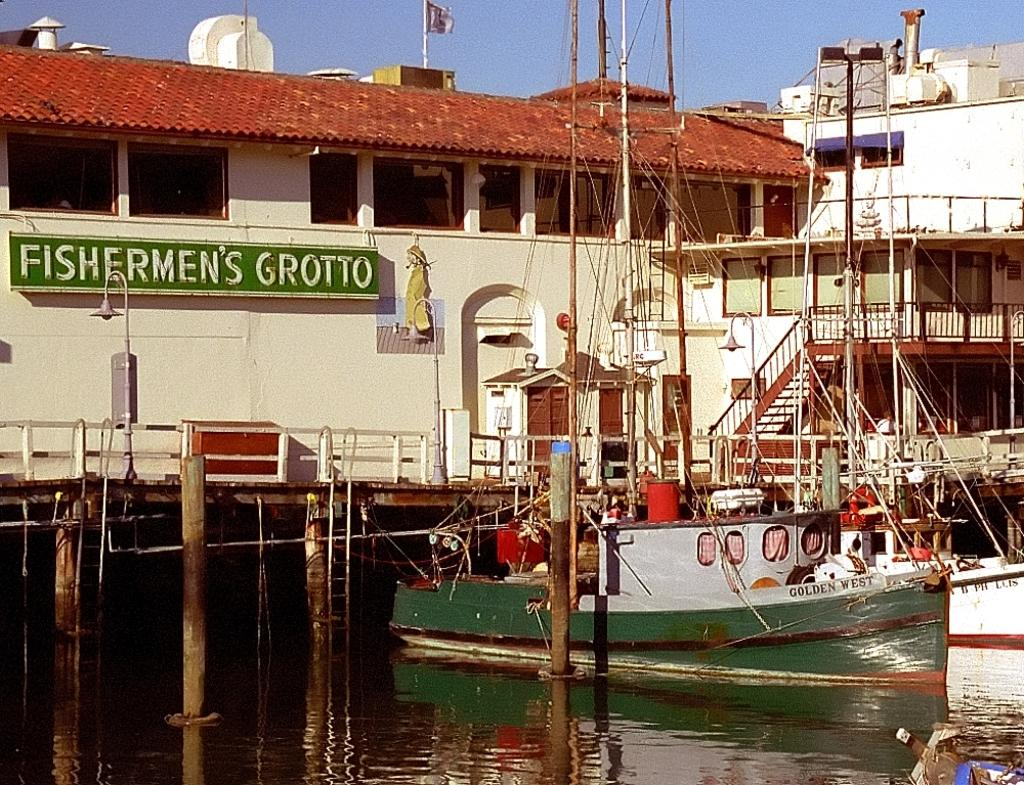<image>
Write a terse but informative summary of the picture. Fishermen's Grotto is in white on green on a dockside scene. 